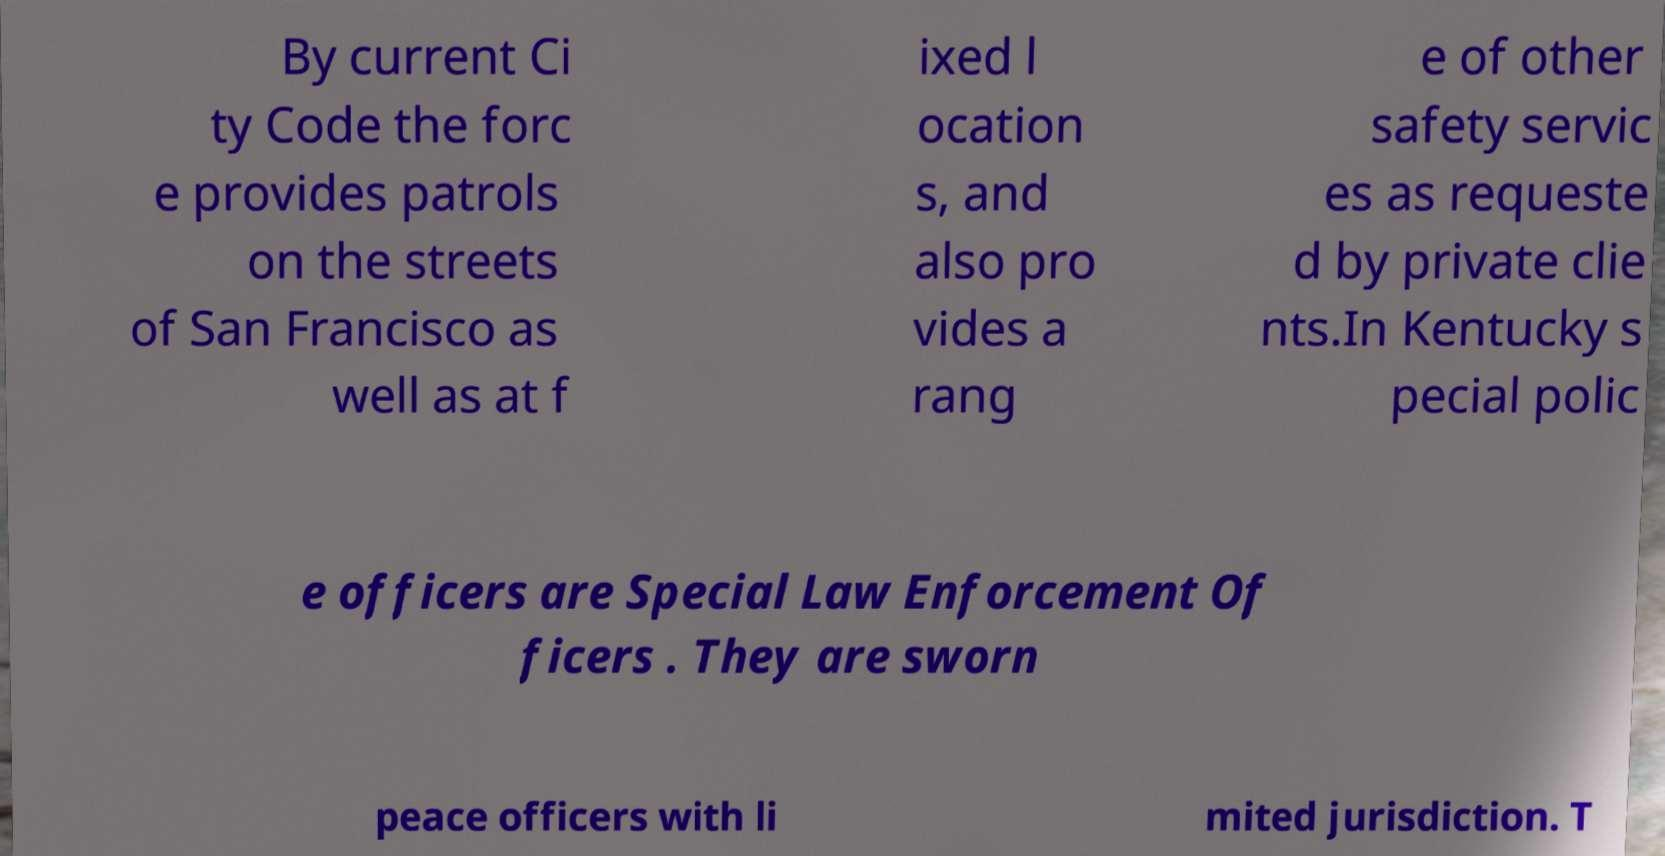Can you read and provide the text displayed in the image?This photo seems to have some interesting text. Can you extract and type it out for me? By current Ci ty Code the forc e provides patrols on the streets of San Francisco as well as at f ixed l ocation s, and also pro vides a rang e of other safety servic es as requeste d by private clie nts.In Kentucky s pecial polic e officers are Special Law Enforcement Of ficers . They are sworn peace officers with li mited jurisdiction. T 